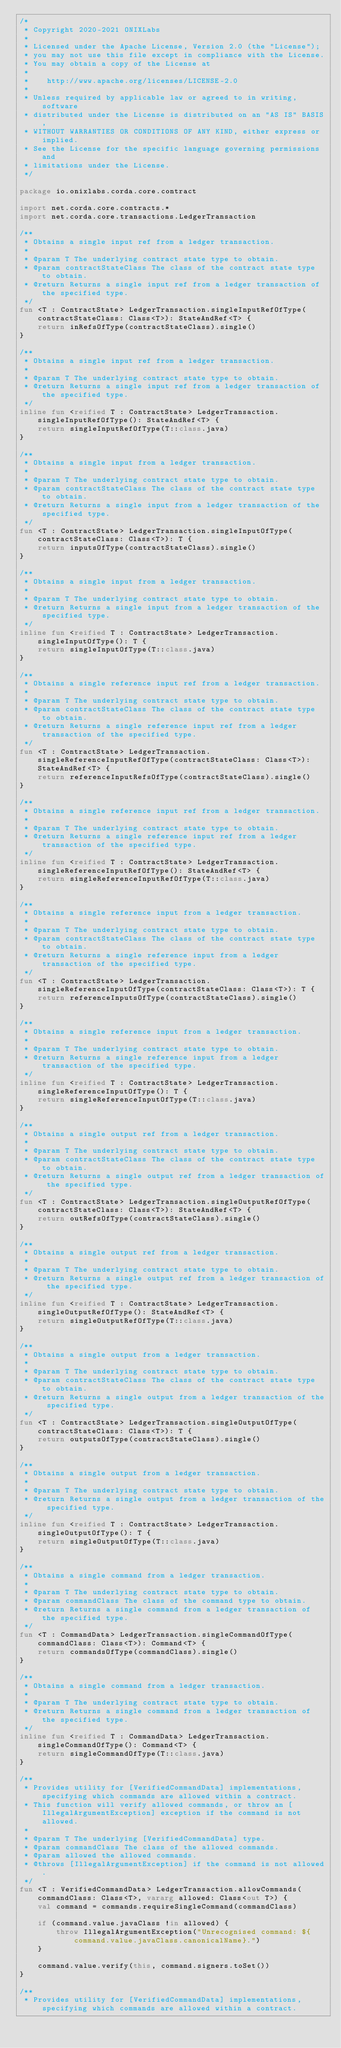Convert code to text. <code><loc_0><loc_0><loc_500><loc_500><_Kotlin_>/*
 * Copyright 2020-2021 ONIXLabs
 *
 * Licensed under the Apache License, Version 2.0 (the "License");
 * you may not use this file except in compliance with the License.
 * You may obtain a copy of the License at
 *
 *    http://www.apache.org/licenses/LICENSE-2.0
 *
 * Unless required by applicable law or agreed to in writing, software
 * distributed under the License is distributed on an "AS IS" BASIS,
 * WITHOUT WARRANTIES OR CONDITIONS OF ANY KIND, either express or implied.
 * See the License for the specific language governing permissions and
 * limitations under the License.
 */

package io.onixlabs.corda.core.contract

import net.corda.core.contracts.*
import net.corda.core.transactions.LedgerTransaction

/**
 * Obtains a single input ref from a ledger transaction.
 *
 * @param T The underlying contract state type to obtain.
 * @param contractStateClass The class of the contract state type to obtain.
 * @return Returns a single input ref from a ledger transaction of the specified type.
 */
fun <T : ContractState> LedgerTransaction.singleInputRefOfType(contractStateClass: Class<T>): StateAndRef<T> {
    return inRefsOfType(contractStateClass).single()
}

/**
 * Obtains a single input ref from a ledger transaction.
 *
 * @param T The underlying contract state type to obtain.
 * @return Returns a single input ref from a ledger transaction of the specified type.
 */
inline fun <reified T : ContractState> LedgerTransaction.singleInputRefOfType(): StateAndRef<T> {
    return singleInputRefOfType(T::class.java)
}

/**
 * Obtains a single input from a ledger transaction.
 *
 * @param T The underlying contract state type to obtain.
 * @param contractStateClass The class of the contract state type to obtain.
 * @return Returns a single input from a ledger transaction of the specified type.
 */
fun <T : ContractState> LedgerTransaction.singleInputOfType(contractStateClass: Class<T>): T {
    return inputsOfType(contractStateClass).single()
}

/**
 * Obtains a single input from a ledger transaction.
 *
 * @param T The underlying contract state type to obtain.
 * @return Returns a single input from a ledger transaction of the specified type.
 */
inline fun <reified T : ContractState> LedgerTransaction.singleInputOfType(): T {
    return singleInputOfType(T::class.java)
}

/**
 * Obtains a single reference input ref from a ledger transaction.
 *
 * @param T The underlying contract state type to obtain.
 * @param contractStateClass The class of the contract state type to obtain.
 * @return Returns a single reference input ref from a ledger transaction of the specified type.
 */
fun <T : ContractState> LedgerTransaction.singleReferenceInputRefOfType(contractStateClass: Class<T>): StateAndRef<T> {
    return referenceInputRefsOfType(contractStateClass).single()
}

/**
 * Obtains a single reference input ref from a ledger transaction.
 *
 * @param T The underlying contract state type to obtain.
 * @return Returns a single reference input ref from a ledger transaction of the specified type.
 */
inline fun <reified T : ContractState> LedgerTransaction.singleReferenceInputRefOfType(): StateAndRef<T> {
    return singleReferenceInputRefOfType(T::class.java)
}

/**
 * Obtains a single reference input from a ledger transaction.
 *
 * @param T The underlying contract state type to obtain.
 * @param contractStateClass The class of the contract state type to obtain.
 * @return Returns a single reference input from a ledger transaction of the specified type.
 */
fun <T : ContractState> LedgerTransaction.singleReferenceInputOfType(contractStateClass: Class<T>): T {
    return referenceInputsOfType(contractStateClass).single()
}

/**
 * Obtains a single reference input from a ledger transaction.
 *
 * @param T The underlying contract state type to obtain.
 * @return Returns a single reference input from a ledger transaction of the specified type.
 */
inline fun <reified T : ContractState> LedgerTransaction.singleReferenceInputOfType(): T {
    return singleReferenceInputOfType(T::class.java)
}

/**
 * Obtains a single output ref from a ledger transaction.
 *
 * @param T The underlying contract state type to obtain.
 * @param contractStateClass The class of the contract state type to obtain.
 * @return Returns a single output ref from a ledger transaction of the specified type.
 */
fun <T : ContractState> LedgerTransaction.singleOutputRefOfType(contractStateClass: Class<T>): StateAndRef<T> {
    return outRefsOfType(contractStateClass).single()
}

/**
 * Obtains a single output ref from a ledger transaction.
 *
 * @param T The underlying contract state type to obtain.
 * @return Returns a single output ref from a ledger transaction of the specified type.
 */
inline fun <reified T : ContractState> LedgerTransaction.singleOutputRefOfType(): StateAndRef<T> {
    return singleOutputRefOfType(T::class.java)
}

/**
 * Obtains a single output from a ledger transaction.
 *
 * @param T The underlying contract state type to obtain.
 * @param contractStateClass The class of the contract state type to obtain.
 * @return Returns a single output from a ledger transaction of the specified type.
 */
fun <T : ContractState> LedgerTransaction.singleOutputOfType(contractStateClass: Class<T>): T {
    return outputsOfType(contractStateClass).single()
}

/**
 * Obtains a single output from a ledger transaction.
 *
 * @param T The underlying contract state type to obtain.
 * @return Returns a single output from a ledger transaction of the specified type.
 */
inline fun <reified T : ContractState> LedgerTransaction.singleOutputOfType(): T {
    return singleOutputOfType(T::class.java)
}

/**
 * Obtains a single command from a ledger transaction.
 *
 * @param T The underlying contract state type to obtain.
 * @param commandClass The class of the command type to obtain.
 * @return Returns a single command from a ledger transaction of the specified type.
 */
fun <T : CommandData> LedgerTransaction.singleCommandOfType(commandClass: Class<T>): Command<T> {
    return commandsOfType(commandClass).single()
}

/**
 * Obtains a single command from a ledger transaction.
 *
 * @param T The underlying contract state type to obtain.
 * @return Returns a single command from a ledger transaction of the specified type.
 */
inline fun <reified T : CommandData> LedgerTransaction.singleCommandOfType(): Command<T> {
    return singleCommandOfType(T::class.java)
}

/**
 * Provides utility for [VerifiedCommandData] implementations, specifying which commands are allowed within a contract.
 * This function will verify allowed commands, or throw an [IllegalArgumentException] exception if the command is not allowed.
 *
 * @param T The underlying [VerifiedCommandData] type.
 * @param commandClass The class of the allowed commands.
 * @param allowed the allowed commands.
 * @throws [IllegalArgumentException] if the command is not allowed.
 */
fun <T : VerifiedCommandData> LedgerTransaction.allowCommands(commandClass: Class<T>, vararg allowed: Class<out T>) {
    val command = commands.requireSingleCommand(commandClass)

    if (command.value.javaClass !in allowed) {
        throw IllegalArgumentException("Unrecognised command: ${command.value.javaClass.canonicalName}.")
    }

    command.value.verify(this, command.signers.toSet())
}

/**
 * Provides utility for [VerifiedCommandData] implementations, specifying which commands are allowed within a contract.</code> 